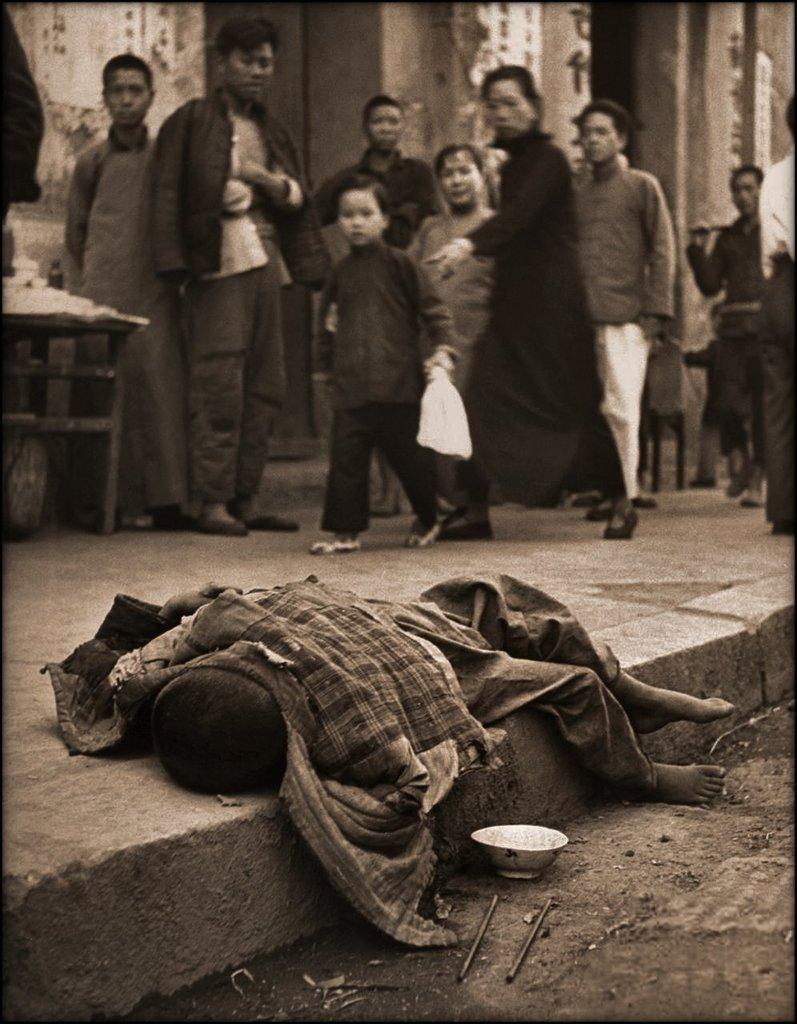What is the main subject of the image? There is a person sleeping on the floor in the image. Can you describe the people in the background? There are other persons standing in the background. What is the person in front holding? The person in front is holding a cover. What is the color scheme of the image? The image is in black and white. What type of salt can be seen on the person's tongue in the image? There is no salt or any indication of taste in the image; it only shows a person sleeping on the floor and others standing in the background. 